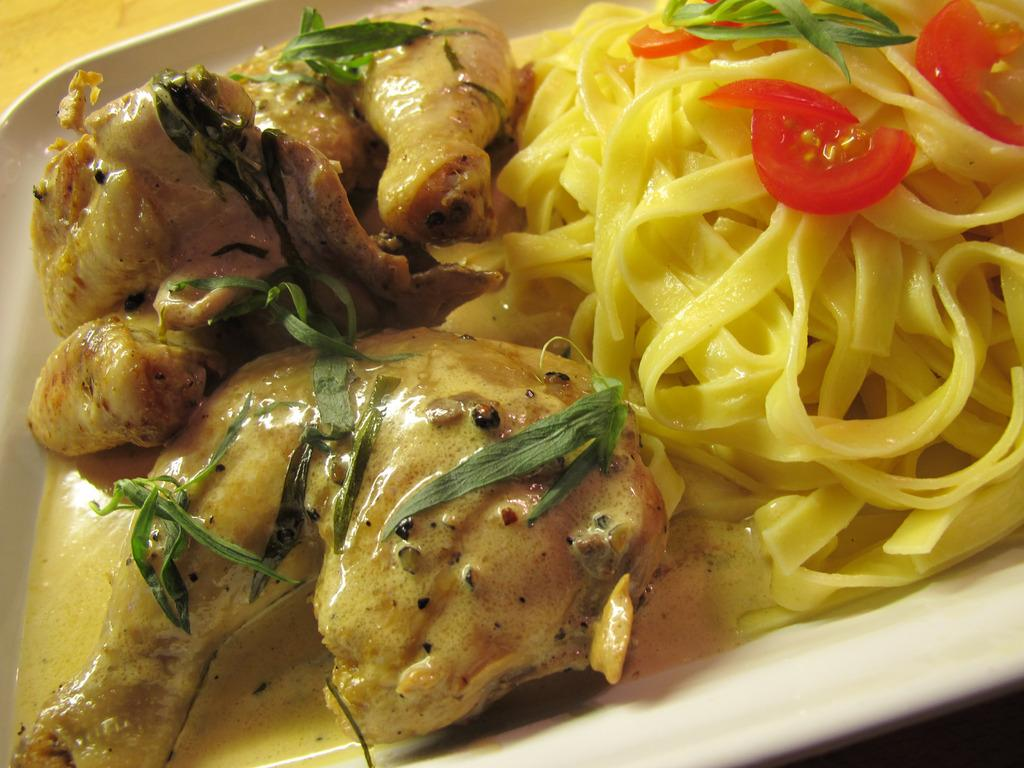What object is present in the image that might be used for serving or presenting food? There is a plate in the image. What can be found on the plate in the image? There are food items on the plate. What type of writing can be seen on the plate in the image? There is no writing visible on the plate in the image. What historical event is depicted on the plate in the image? There is no historical event depicted on the plate in the image. Who is the minister that is present in the image? There is no minister present in the image. 